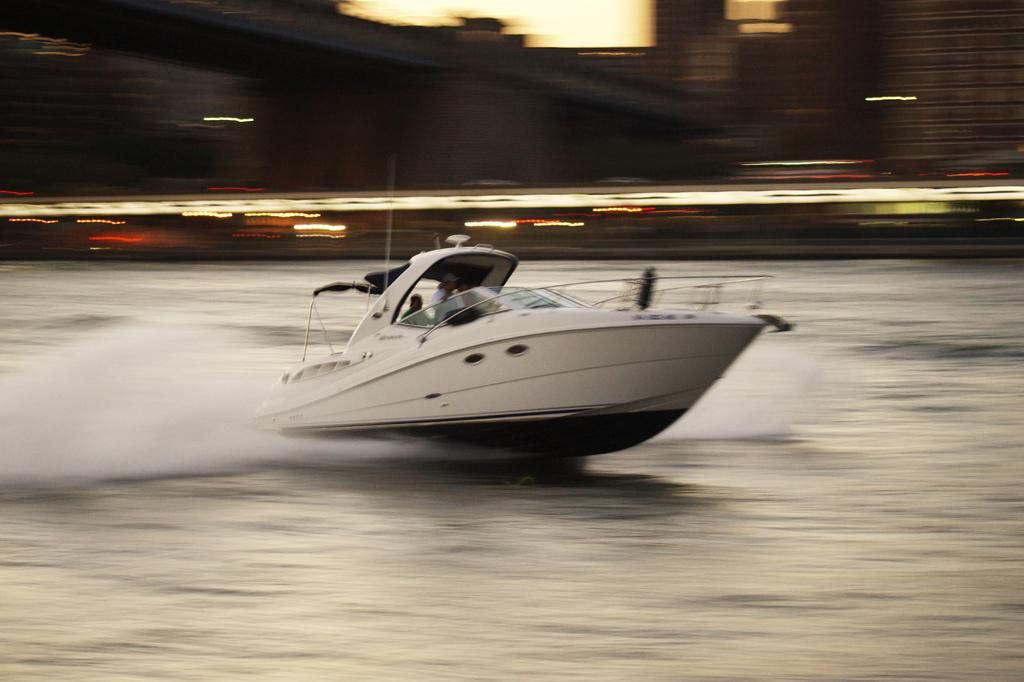What is the main subject of the image? The main subject of the image is a boat. Where is the boat located? The boat is on the water. Are there any people in the boat? Yes, there are people inside the boat. What color is the boat? The boat is white in color. Can you describe the background of the image? The background of the image is blurred. What type of oil can be seen dripping from the boat in the image? There is no oil visible in the image, and the boat is not dripping anything. 